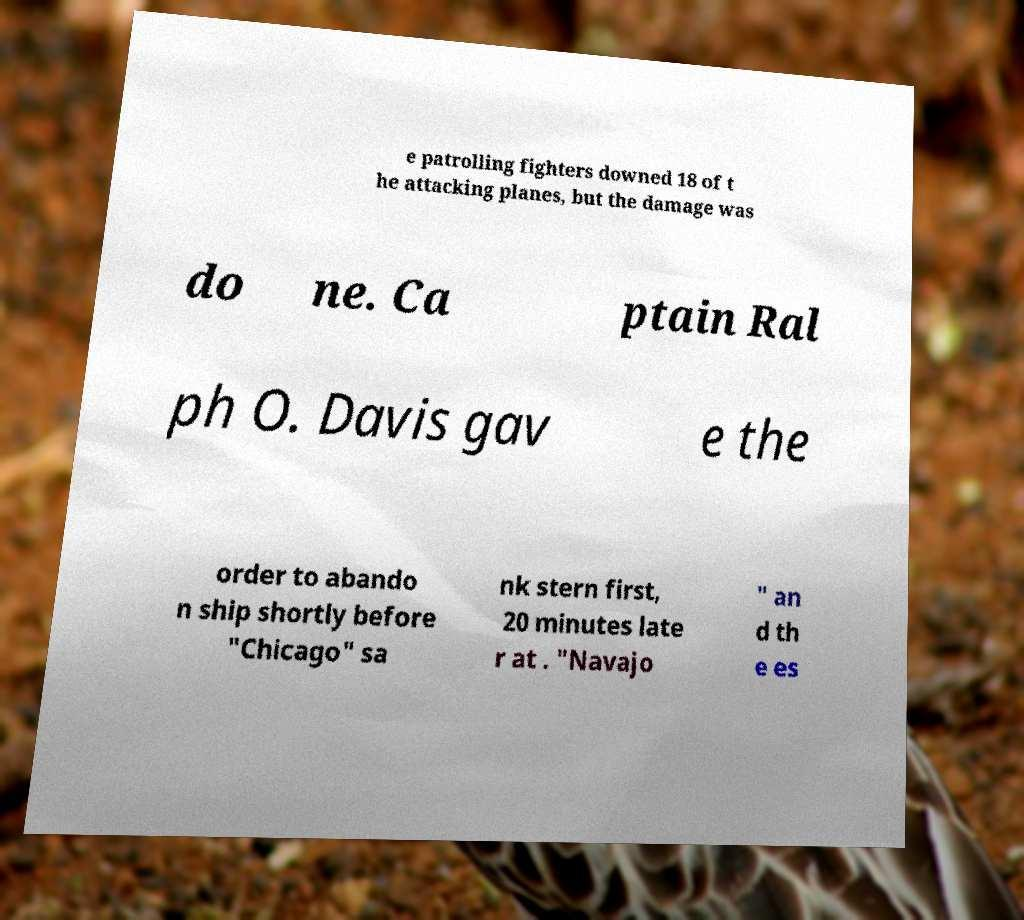Could you extract and type out the text from this image? e patrolling fighters downed 18 of t he attacking planes, but the damage was do ne. Ca ptain Ral ph O. Davis gav e the order to abando n ship shortly before "Chicago" sa nk stern first, 20 minutes late r at . "Navajo " an d th e es 